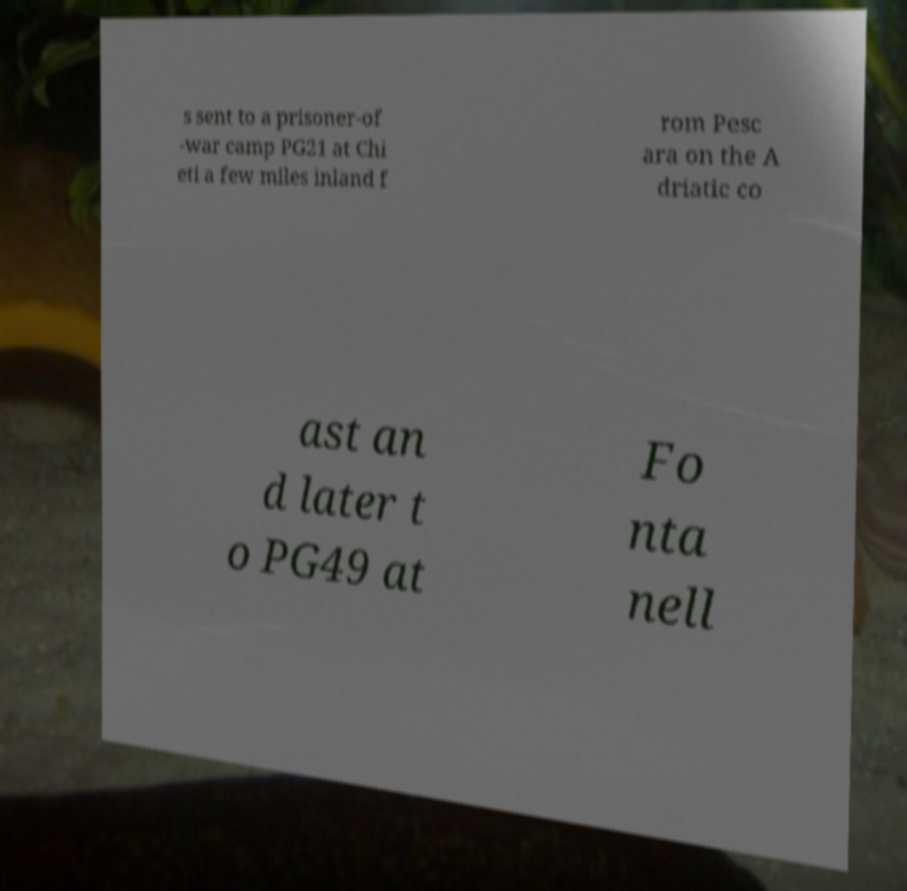Could you assist in decoding the text presented in this image and type it out clearly? s sent to a prisoner-of -war camp PG21 at Chi eti a few miles inland f rom Pesc ara on the A driatic co ast an d later t o PG49 at Fo nta nell 